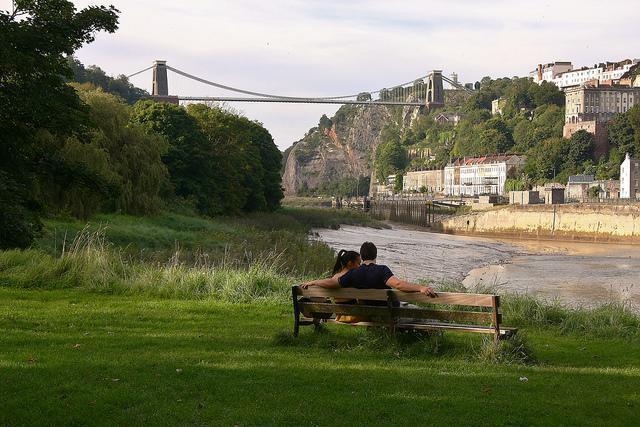How many people are standing up?
Give a very brief answer. 0. 